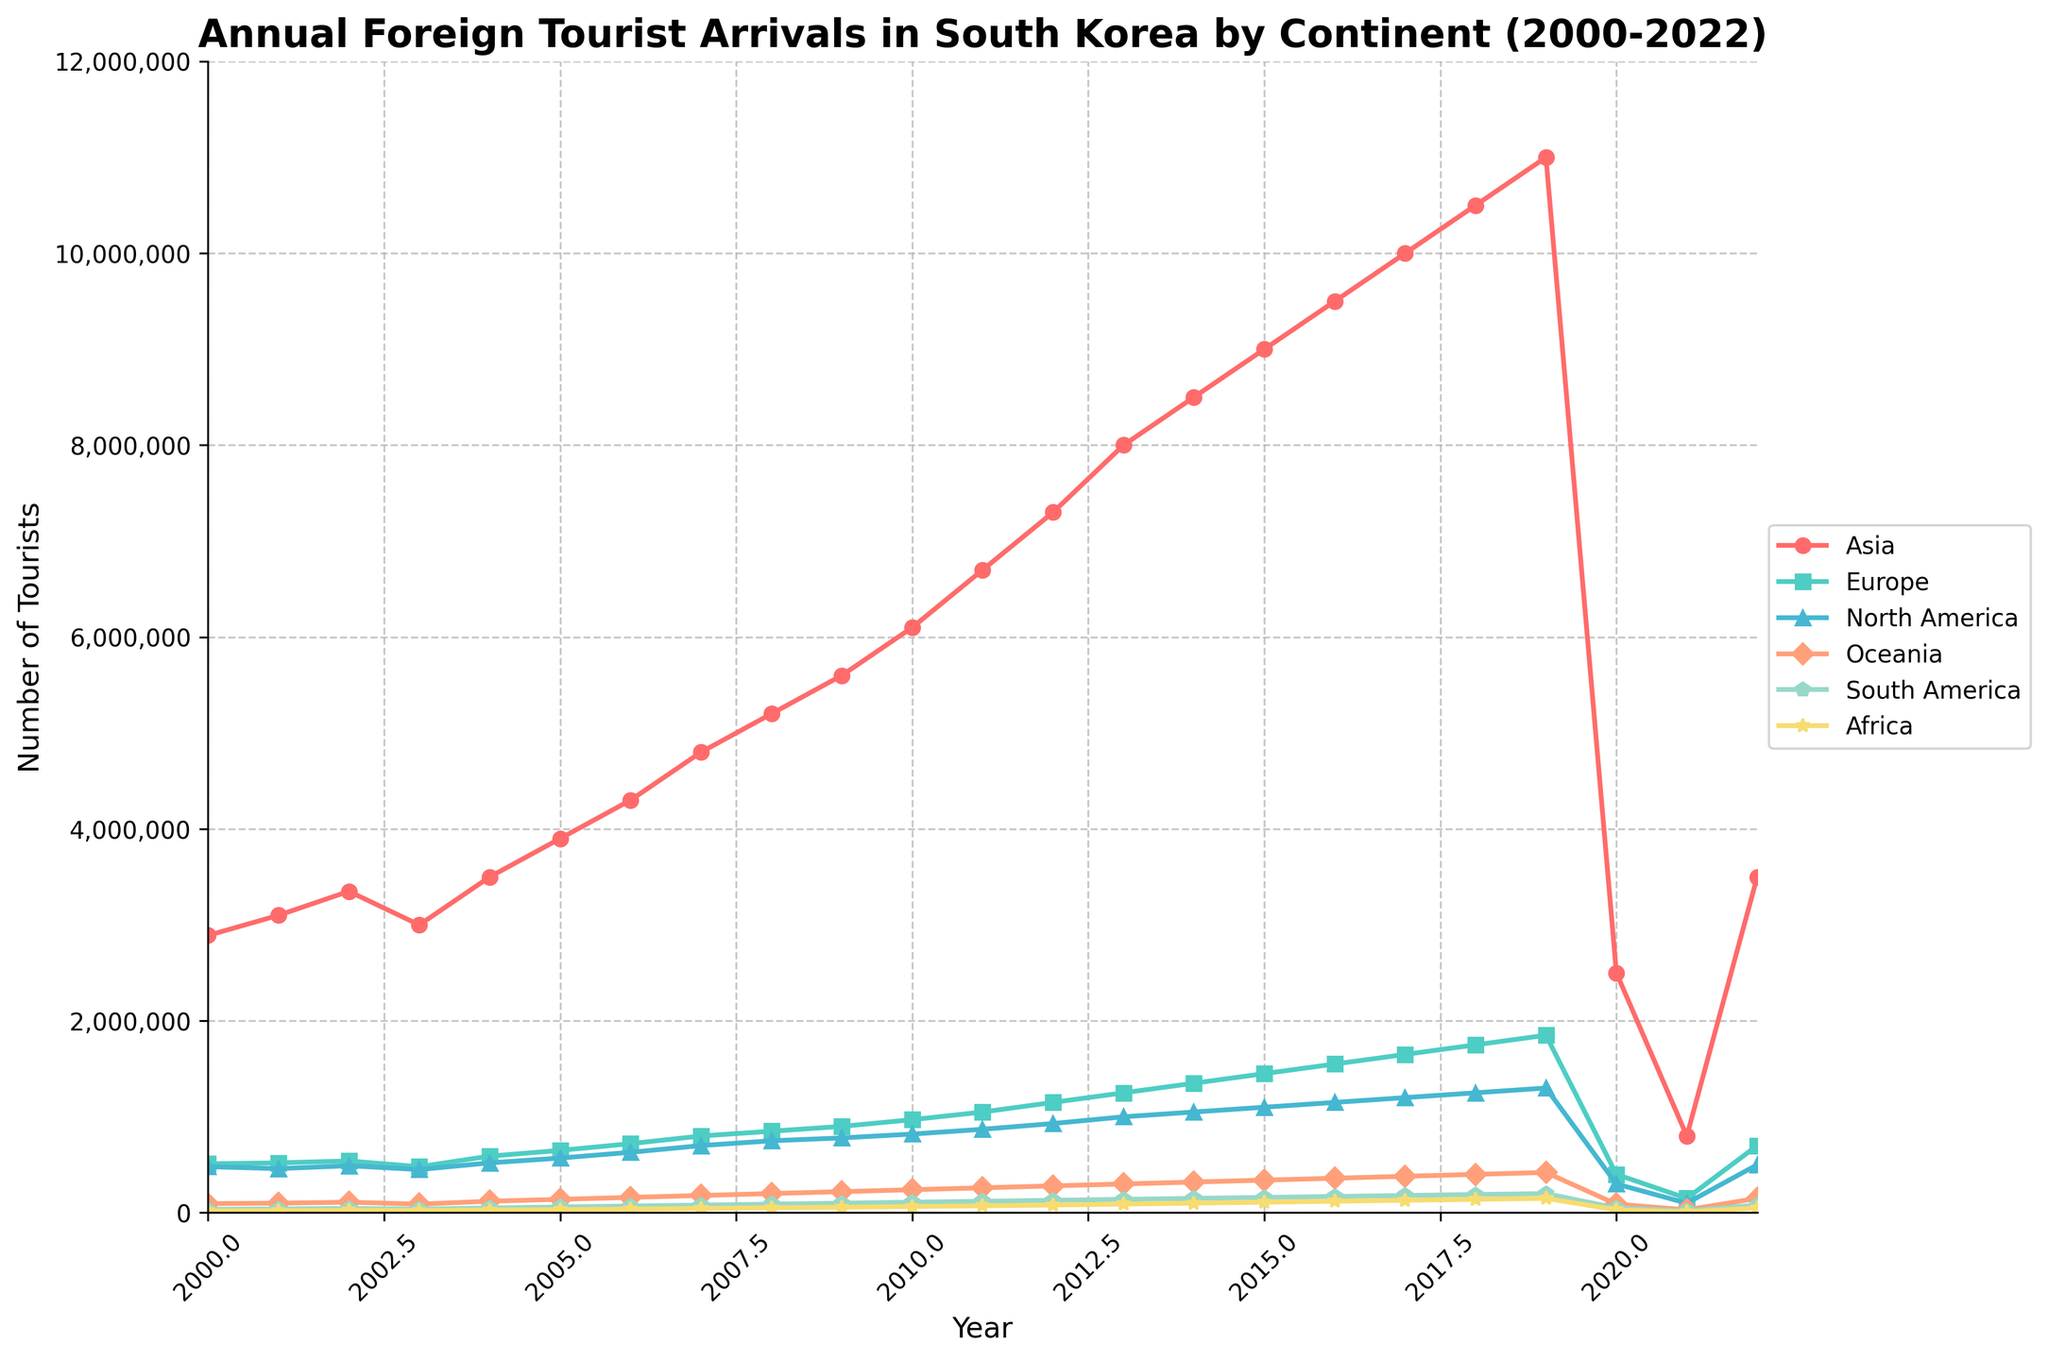what continent had the highest number of tourists in 2018? Look at the graph for 2018 and find the highest point among the lines. The line for Asia is the highest in 2018.
Answer: Asia Which two continents had the smallest difference in tourist numbers in 2020? Find the two lines closest together in 2020. Europe with 400,000 and North America with 300,000 are the closest.
Answer: Europe and North America How much did the number of tourists from Oceania increase from 2000 to 2009? Find the y-values for Oceania in 2000 and 2009, then subtract. 220,000 (2009) - 95,000 (2000) = 125,000.
Answer: 125,000 What was the trend for tourists from North America from 2000 to 2019? Observe the line for North America from 2000 to 2019. The graph shows a generally increasing trend.
Answer: Increasing Compare the tourist numbers from Asia and Europe in 2022. Who had more and by how much? Look at the graph for 2022 and find the values for Asia and Europe. Asia had 3,500,000, and Europe had 700,000. 3,500,000 - 700,000 = 2,800,000.
Answer: Asia by 2,800,000 What was the lowest number of tourists from South America throughout the years? Find the lowest point on the graph for South America. The lowest number occurred in 2000 with 35,000 tourists.
Answer: 35,000 In which year did Asia see its peak number of tourists? Find the peak point of the line representing Asia. The highest point is in 2019, where there were 11,000,000 tourists.
Answer: 2019 Calculate the average number of tourists from Africa between 2000 and 2022. Sum up the values for Africa between 2000 to 2022 and divide by the number of years (23). Sum: 1,970,000, Average: 1,970,000 / 23 ≈ 85,652
Answer: Approximately 85,652 How did the number of tourists from South America change from 2003 to 2022? Compare the y-values for South America in 2003 and 2022. 38,000 (2003) to 80,000 (2022) indicates an increase.
Answer: Increased Which continent experienced the steepest decline in tourist numbers in 2020? Identify the largest drop in the graph from 2019 to 2020. Asia shows the most significant decline from 11,000,000 to 2,500,000.
Answer: Asia 